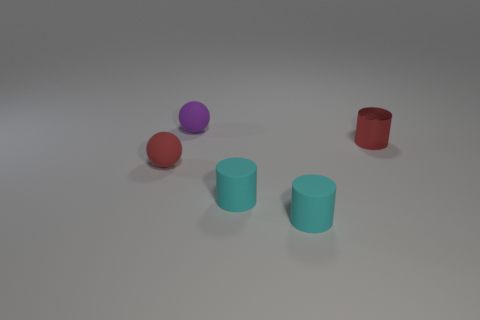What is the shape of the small matte object that is the same color as the shiny object?
Provide a short and direct response. Sphere. What is the color of the object that is on the left side of the tiny purple matte sphere?
Offer a very short reply. Red. Do the tiny purple ball and the tiny red sphere have the same material?
Provide a succinct answer. Yes. What number of objects are tiny red shiny objects or cyan rubber cylinders that are to the right of the tiny red sphere?
Provide a short and direct response. 3. What is the size of the object that is the same color as the small metallic cylinder?
Provide a short and direct response. Small. What shape is the red thing to the left of the purple object?
Keep it short and to the point. Sphere. Does the sphere in front of the small red cylinder have the same color as the metal thing?
Give a very brief answer. Yes. There is another tiny thing that is the same color as the small metallic object; what is its material?
Make the answer very short. Rubber. Does the thing that is left of the purple ball have the same size as the small red shiny object?
Your answer should be very brief. Yes. Are there any rubber objects of the same color as the small metallic cylinder?
Make the answer very short. Yes. 